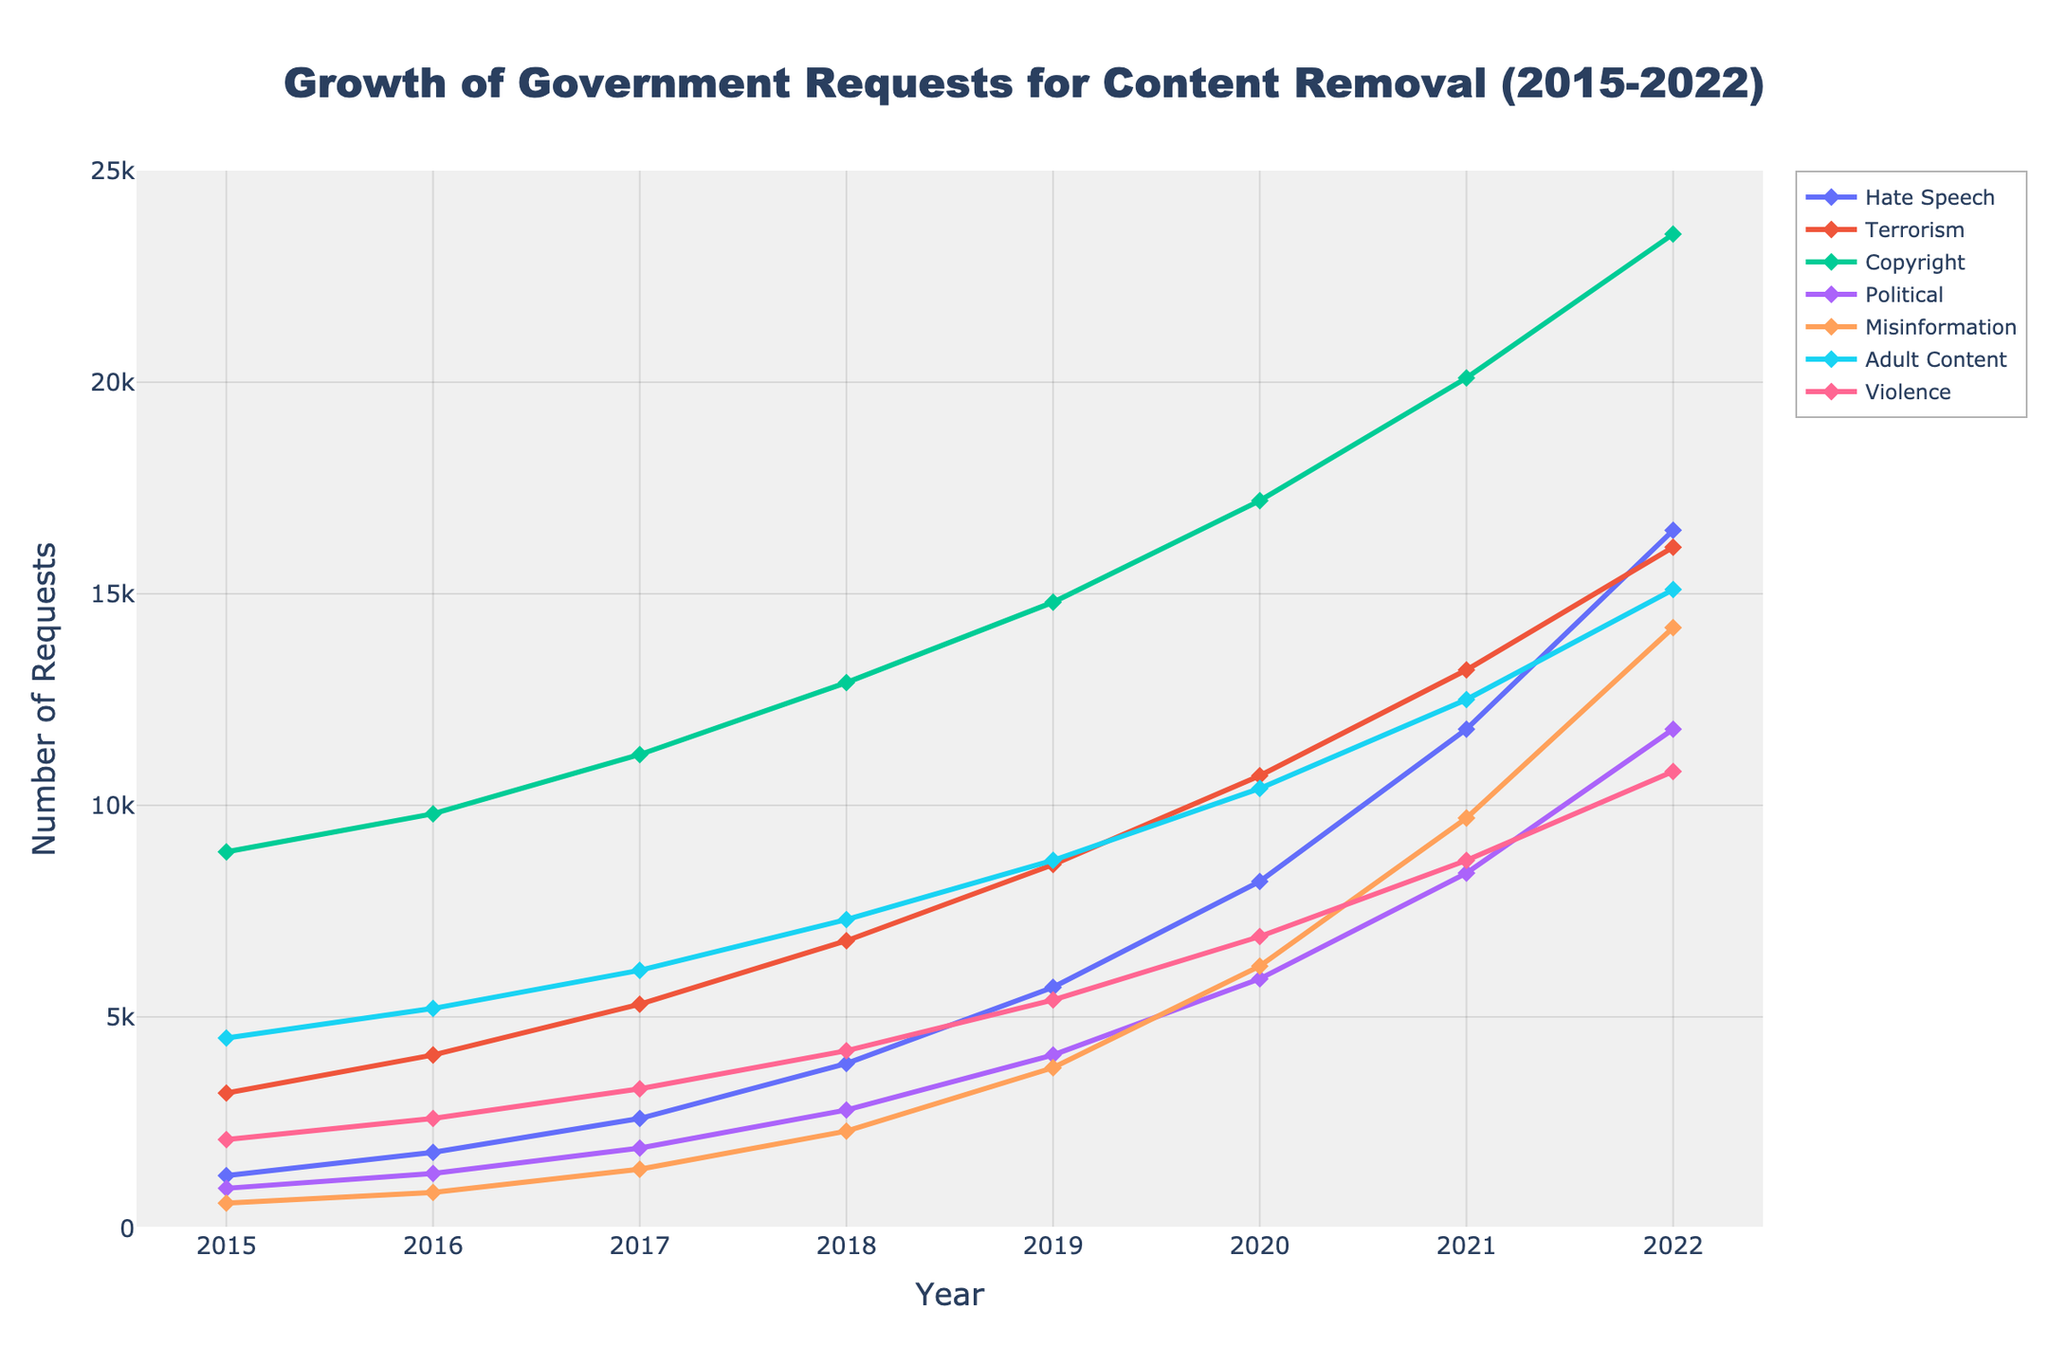What was the percentage increase in government requests for removing hate speech content from 2015 to 2022? First, find the values for hate speech requests in 2015 and 2022, which are 1,250 and 16,500, respectively. The percentage increase is calculated as: \[ \text{Percentage Increase} = \left( \frac{\text{New Value} - \text{Old Value}}{\text{Old Value}} \right) \times 100 \] Substituting the values: \[ \frac{16,500 - 1,250}{1,250} \times 100 = \left( \frac{15,250}{1,250} \right) \times 100 = 12.2 \times 100 = 1,220\% \]
Answer: 1220% In which year did requests for content removal related to terrorism surpass 10,000? Locate the year in which the requests for terrorism are more than 10,000. According to the figure, this happens in 2020 when the requests reach 10,700.
Answer: 2020 How does the trend of government requests for removing political content compare to that for copyright content from 2015 to 2022? Analyze the trend lines of both political and copyright content from 2015 to 2022. Political content shows a steadily increasing trend starting from 950 requests in 2015 to 11,800 in 2022. The copyright content follows a similar increasing trend but starts much higher at 8,900 requests in 2015 and reaches 23,500 in 2022. Both categories show consistent growth but the volume of copyright content requests is significantly higher.
Answer: Both are increasing, but copyright content starts higher and grows to a much higher number How many more requests were made for removing adult content than misinformation in 2022? Take the number of requests for adult content and misinformation in 2022, which are 15,100 and 14,200 respectively. Calculate the difference: \[ 15,100 - 14,200 = 900 \]
Answer: 900 Between which consecutive years did government requests for removing violence-related content experience the highest increase? Examine the data for violence-related content. The increases are as follows:
\[ 2016-2015: 2,600 - 2,100 = 500 \]
\[ 2017-2016: 3,300 - 2,600 = 700 \]
\[ 2018-2017: 4,200 - 3,300 = 900 \]
\[ 2019-2018: 5,400 - 4,200 = 1,200 \]
\[ 2020-2019: 6,900 - 5,400 = 1,500 \]
\[ 2021-2020: 8,700 - 6,900 = 1,800 \]
\[ 2022-2021: 10,800 - 8,700 = 2,100 \]
The highest increase is from 2021 to 2022.
Answer: 2021 to 2022 What is the average number of requests for removing terrorism-related content from 2015 to 2022? Find the total number of requests over these years and then divide by the number of years: \[ 3,200 + 4,100 + 5,300 + 6,800 + 8,600 + 10,700 + 13,200 + 16,100 = 67,000 \] There are 8 years in the given data, so: \[ \frac{67,000}{8} = 8,375 \]
Answer: 8,375 Which content category had the highest number of removal requests in 2022, and what is that number? Identify the category with the highest value in 2022. The categories and their values are: Hate Speech (16,500), Terrorism (16,100), Copyright (23,500), Political (11,800), Misinformation (14,200), Adult Content (15,100), Violence (10,800). The highest value is in Copyright with 23,500 requests.
Answer: Copyright, 23,500 How does the rate of increase in requests for removing hate speech content from 2015 to 2018 compare to the rate from 2018 to 2022? Calculate the total increase for both periods. From 2015 to 2018: \[ 3,900 - 1,250 = 2,650 \] The duration is 3 years, hence the average annual increase in this period: \[ \frac{2,650}{3} \approx 883 \] From 2018 to 2022: \[ 16,500 - 3,900 = 12,600 \] The duration here is 4 years, thus the average annual increase: \[ \frac{12,600}{4} = 3,150 \] The rate of increase is much higher from 2018 to 2022.
Answer: Higher from 2018 to 2022 What is the total number of government requests for removing political content across all years shown? Sum the values of government requests for political content from 2015 to 2022: \[ 950 + 1,300 + 1,900 + 2,800 + 4,100 + 5,900 + 8,400 + 11,800 = 37,150 \]
Answer: 37,150 